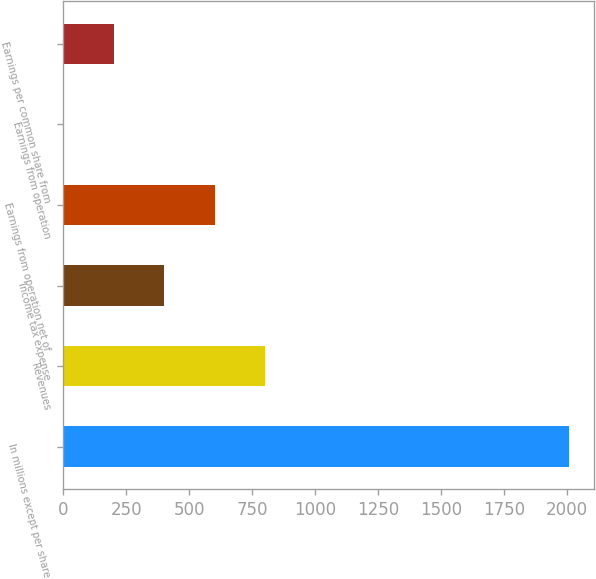<chart> <loc_0><loc_0><loc_500><loc_500><bar_chart><fcel>In millions except per share<fcel>Revenues<fcel>Income tax expense<fcel>Earnings from operation net of<fcel>Earnings from operation<fcel>Earnings per common share from<nl><fcel>2005<fcel>802.04<fcel>401.05<fcel>601.55<fcel>0.05<fcel>200.55<nl></chart> 